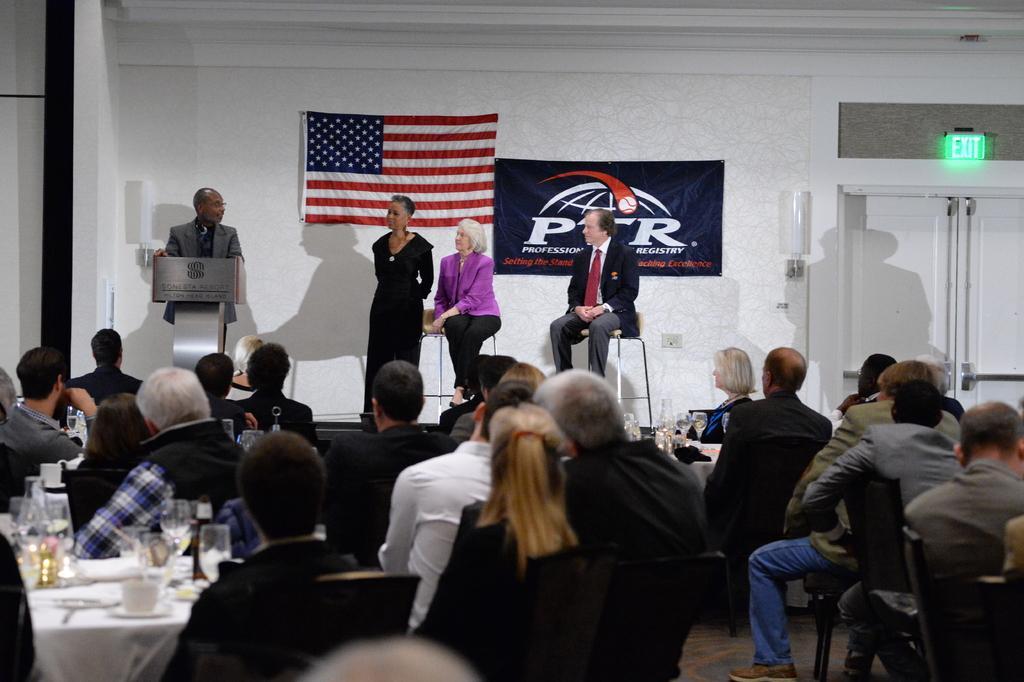Please provide a concise description of this image. Group of people are listening to a man who is standing at a podium. There three other people standing beside him on the stage. 